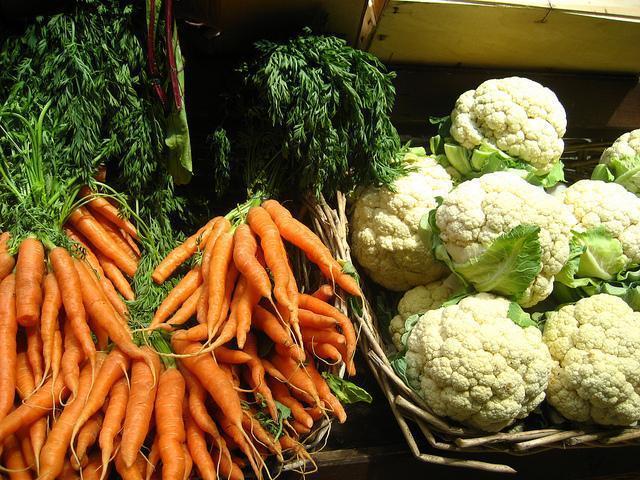How many carrots are visible?
Give a very brief answer. 8. How many laptops are on the table?
Give a very brief answer. 0. 